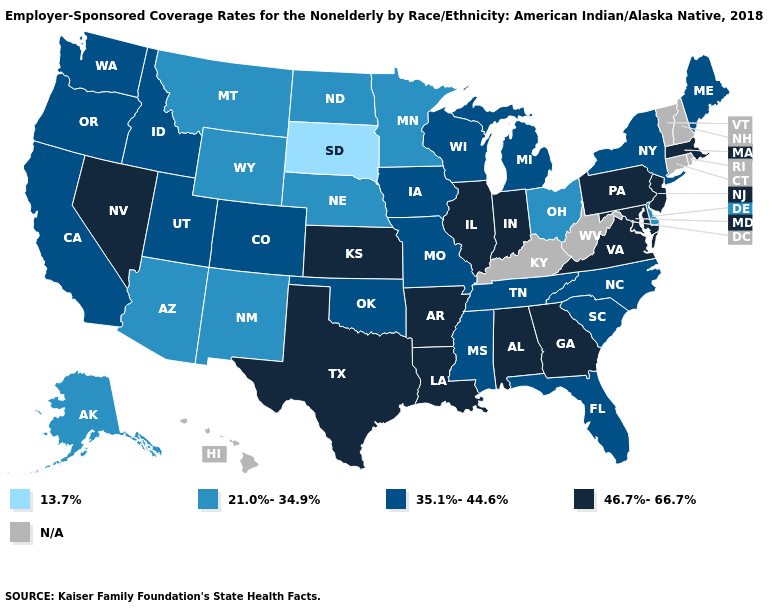Name the states that have a value in the range N/A?
Answer briefly. Connecticut, Hawaii, Kentucky, New Hampshire, Rhode Island, Vermont, West Virginia. What is the lowest value in states that border Nevada?
Quick response, please. 21.0%-34.9%. Does Indiana have the lowest value in the MidWest?
Answer briefly. No. Name the states that have a value in the range 35.1%-44.6%?
Give a very brief answer. California, Colorado, Florida, Idaho, Iowa, Maine, Michigan, Mississippi, Missouri, New York, North Carolina, Oklahoma, Oregon, South Carolina, Tennessee, Utah, Washington, Wisconsin. Is the legend a continuous bar?
Concise answer only. No. What is the value of West Virginia?
Keep it brief. N/A. What is the lowest value in states that border New Jersey?
Quick response, please. 21.0%-34.9%. What is the value of Florida?
Quick response, please. 35.1%-44.6%. Does New York have the highest value in the USA?
Write a very short answer. No. Which states have the highest value in the USA?
Keep it brief. Alabama, Arkansas, Georgia, Illinois, Indiana, Kansas, Louisiana, Maryland, Massachusetts, Nevada, New Jersey, Pennsylvania, Texas, Virginia. Name the states that have a value in the range N/A?
Quick response, please. Connecticut, Hawaii, Kentucky, New Hampshire, Rhode Island, Vermont, West Virginia. Does Arkansas have the highest value in the South?
Quick response, please. Yes. Does North Dakota have the lowest value in the USA?
Quick response, please. No. Does New Mexico have the lowest value in the West?
Quick response, please. Yes. Does Virginia have the highest value in the South?
Concise answer only. Yes. 